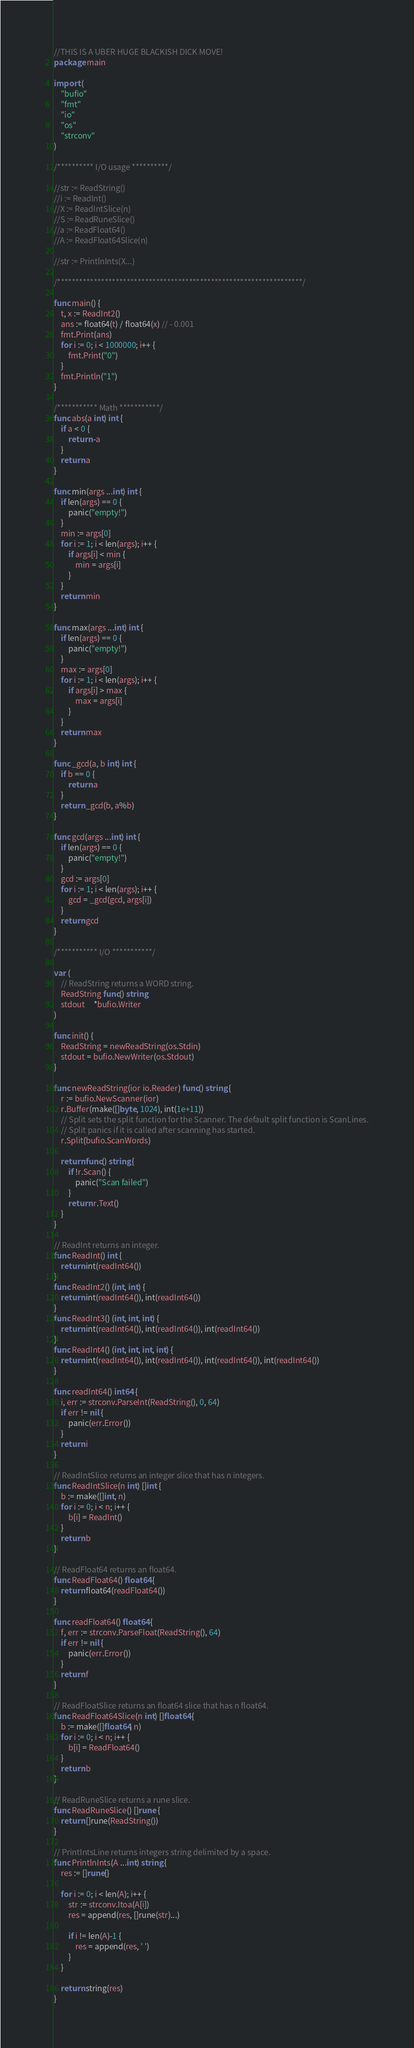<code> <loc_0><loc_0><loc_500><loc_500><_Go_>//THIS IS A UBER HUGE BLACKISH DICK MOVE!
package main

import (
	"bufio"
	"fmt"
	"io"
	"os"
	"strconv"
)

/********** I/O usage **********/

//str := ReadString()
//i := ReadInt()
//X := ReadIntSlice(n)
//S := ReadRuneSlice()
//a := ReadFloat64()
//A := ReadFloat64Slice(n)

//str := PrintlnInts(X...)

/*******************************************************************/

func main() {
	t, x := ReadInt2()
	ans := float64(t) / float64(x) // - 0.001
	fmt.Print(ans)
	for i := 0; i < 1000000; i++ {
		fmt.Print("0")
	}
	fmt.Println("1")
}

/*********** Math ***********/
func abs(a int) int {
	if a < 0 {
		return -a
	}
	return a
}

func min(args ...int) int {
	if len(args) == 0 {
		panic("empty!")
	}
	min := args[0]
	for i := 1; i < len(args); i++ {
		if args[i] < min {
			min = args[i]
		}
	}
	return min
}

func max(args ...int) int {
	if len(args) == 0 {
		panic("empty!")
	}
	max := args[0]
	for i := 1; i < len(args); i++ {
		if args[i] > max {
			max = args[i]
		}
	}
	return max
}

func _gcd(a, b int) int {
	if b == 0 {
		return a
	}
	return _gcd(b, a%b)
}

func gcd(args ...int) int {
	if len(args) == 0 {
		panic("empty!")
	}
	gcd := args[0]
	for i := 1; i < len(args); i++ {
		gcd = _gcd(gcd, args[i])
	}
	return gcd
}

/*********** I/O ***********/

var (
	// ReadString returns a WORD string.
	ReadString func() string
	stdout     *bufio.Writer
)

func init() {
	ReadString = newReadString(os.Stdin)
	stdout = bufio.NewWriter(os.Stdout)
}

func newReadString(ior io.Reader) func() string {
	r := bufio.NewScanner(ior)
	r.Buffer(make([]byte, 1024), int(1e+11))
	// Split sets the split function for the Scanner. The default split function is ScanLines.
	// Split panics if it is called after scanning has started.
	r.Split(bufio.ScanWords)

	return func() string {
		if !r.Scan() {
			panic("Scan failed")
		}
		return r.Text()
	}
}

// ReadInt returns an integer.
func ReadInt() int {
	return int(readInt64())
}
func ReadInt2() (int, int) {
	return int(readInt64()), int(readInt64())
}
func ReadInt3() (int, int, int) {
	return int(readInt64()), int(readInt64()), int(readInt64())
}
func ReadInt4() (int, int, int, int) {
	return int(readInt64()), int(readInt64()), int(readInt64()), int(readInt64())
}

func readInt64() int64 {
	i, err := strconv.ParseInt(ReadString(), 0, 64)
	if err != nil {
		panic(err.Error())
	}
	return i
}

// ReadIntSlice returns an integer slice that has n integers.
func ReadIntSlice(n int) []int {
	b := make([]int, n)
	for i := 0; i < n; i++ {
		b[i] = ReadInt()
	}
	return b
}

// ReadFloat64 returns an float64.
func ReadFloat64() float64 {
	return float64(readFloat64())
}

func readFloat64() float64 {
	f, err := strconv.ParseFloat(ReadString(), 64)
	if err != nil {
		panic(err.Error())
	}
	return f
}

// ReadFloatSlice returns an float64 slice that has n float64.
func ReadFloat64Slice(n int) []float64 {
	b := make([]float64, n)
	for i := 0; i < n; i++ {
		b[i] = ReadFloat64()
	}
	return b
}

// ReadRuneSlice returns a rune slice.
func ReadRuneSlice() []rune {
	return []rune(ReadString())
}

// PrintIntsLine returns integers string delimited by a space.
func PrintlnInts(A ...int) string {
	res := []rune{}

	for i := 0; i < len(A); i++ {
		str := strconv.Itoa(A[i])
		res = append(res, []rune(str)...)

		if i != len(A)-1 {
			res = append(res, ' ')
		}
	}

	return string(res)
}
</code> 